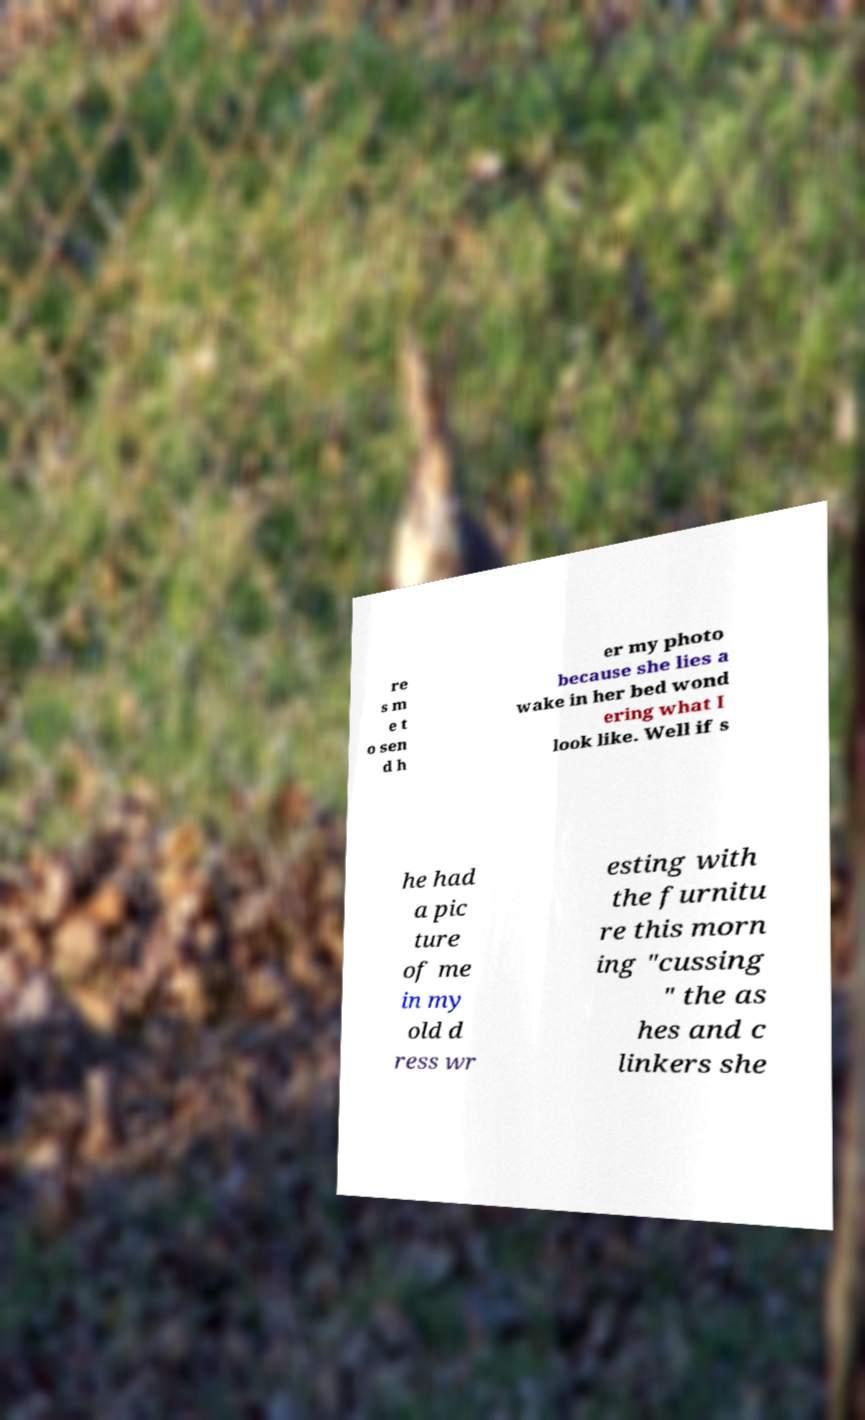Could you extract and type out the text from this image? re s m e t o sen d h er my photo because she lies a wake in her bed wond ering what I look like. Well if s he had a pic ture of me in my old d ress wr esting with the furnitu re this morn ing "cussing " the as hes and c linkers she 